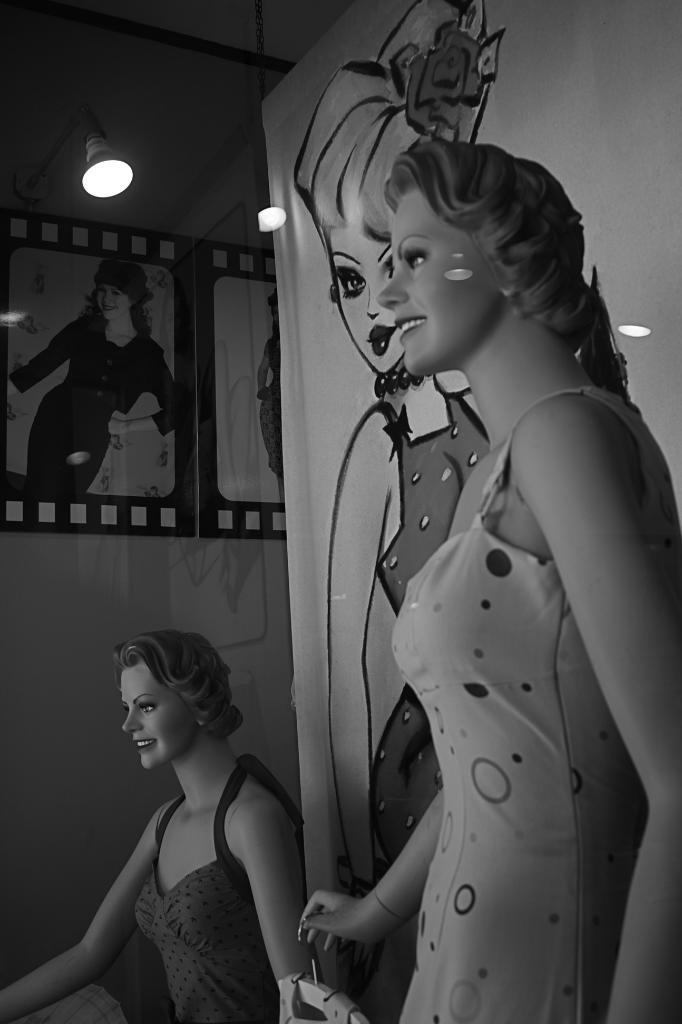What type of figures can be seen in the image? There are mannequins in the image. What else is present in the image besides the mannequins? There are posters and lights in the image. How many pigs are flying in the air in the image? There are no pigs present in the image, and therefore no pigs are flying in the air. What type of stick is being used by the mannequins in the image? There are no sticks present in the image, and the mannequins are not holding or using any objects. 